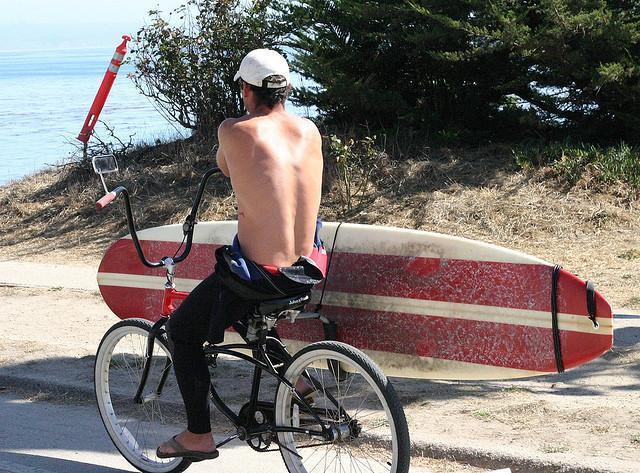How many surfboards are there?
Give a very brief answer. 1. How many pizzas are on the table?
Give a very brief answer. 0. 